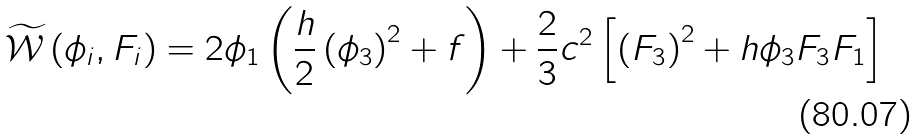<formula> <loc_0><loc_0><loc_500><loc_500>\widetilde { { \mathcal { W } } } \left ( \phi _ { i } , F _ { i } \right ) = 2 \phi _ { 1 } \left ( \frac { h } { 2 } \left ( \phi _ { 3 } \right ) ^ { 2 } + f \right ) + \frac { 2 } { 3 } c ^ { 2 } \left [ \left ( F _ { 3 } \right ) ^ { 2 } + h \phi _ { 3 } F _ { 3 } F _ { 1 } \right ]</formula> 